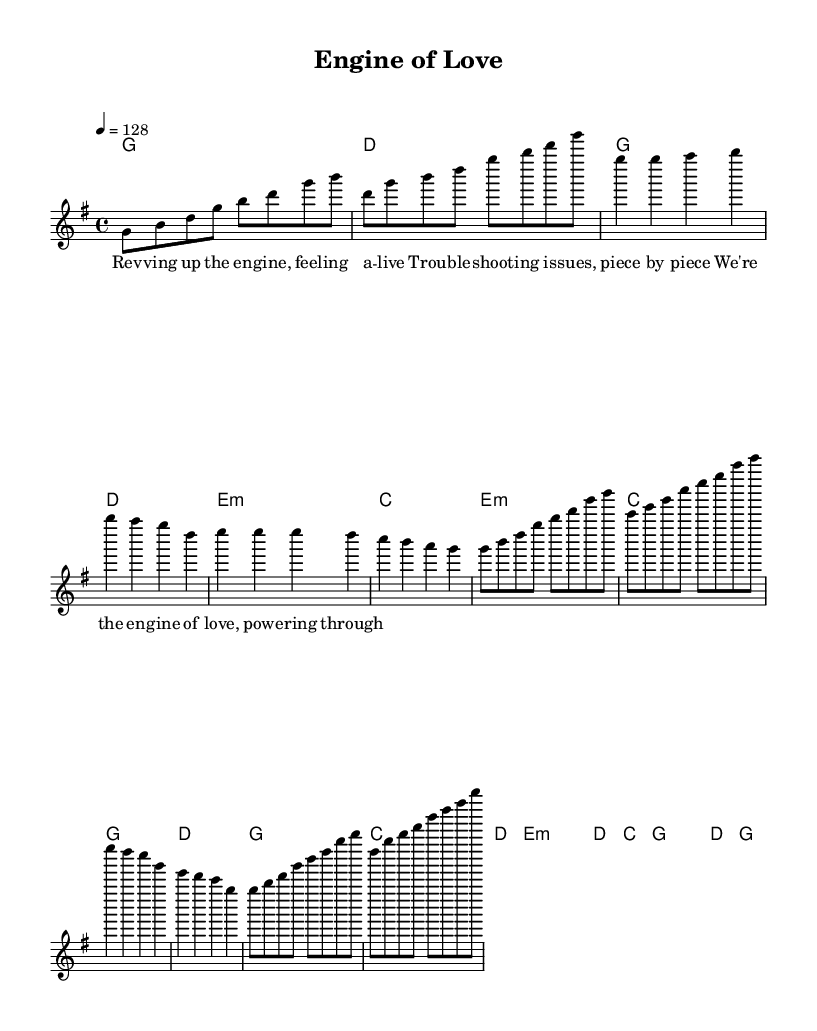What is the key signature of this music? The key signature is G major, which has one sharp (F#). This can be identified at the beginning of the score, where the key signature is indicated.
Answer: G major What is the time signature of this piece? The time signature is 4/4, as indicated at the beginning of the music sheet. This means there are four beats in each measure, and the quarter note gets one beat.
Answer: 4/4 What is the tempo marking for this piece? The tempo marking is indicated as 4 = 128, meaning the piece should be played at a speed of 128 beats per minute, and “4” refers to the quarter note. The tempo is important for maintaining the upbeat feel typical in K-Pop music.
Answer: 128 How many measures are there in the chorus? The chorus consists of four measures, which can be counted in the section of the music labeled "Chorus". Each measure consists of a specific melody and harmony that contributes to the overall structure.
Answer: 4 What is the mood conveyed by the lyrics in the pre-chorus section? The lyrics in the pre-chorus focus on troubleshooting and resolving issues, which conveys a sense of determination and problem-solving. The words describe a proactive approach to challenges, common in K-Pop themes.
Answer: Determination What does the title "Engine of Love" suggest about the song's theme? The title suggests a metaphorical link between machinery (engine) and love, indicating that the song may explore themes of passion and emotional drive similar to how an engine powers a vehicle. This reflects the energetic and innovative style often found in K-Pop.
Answer: Passion What type of musical structure is employed in this K-Pop track? The structure includes verses, a pre-chorus, and a chorus, which is typical for K-Pop songs. This form allows the narrative to build up and release energy through the chorus, creating a diverse listening experience.
Answer: Verse-Pre-Chorus-Chorus 